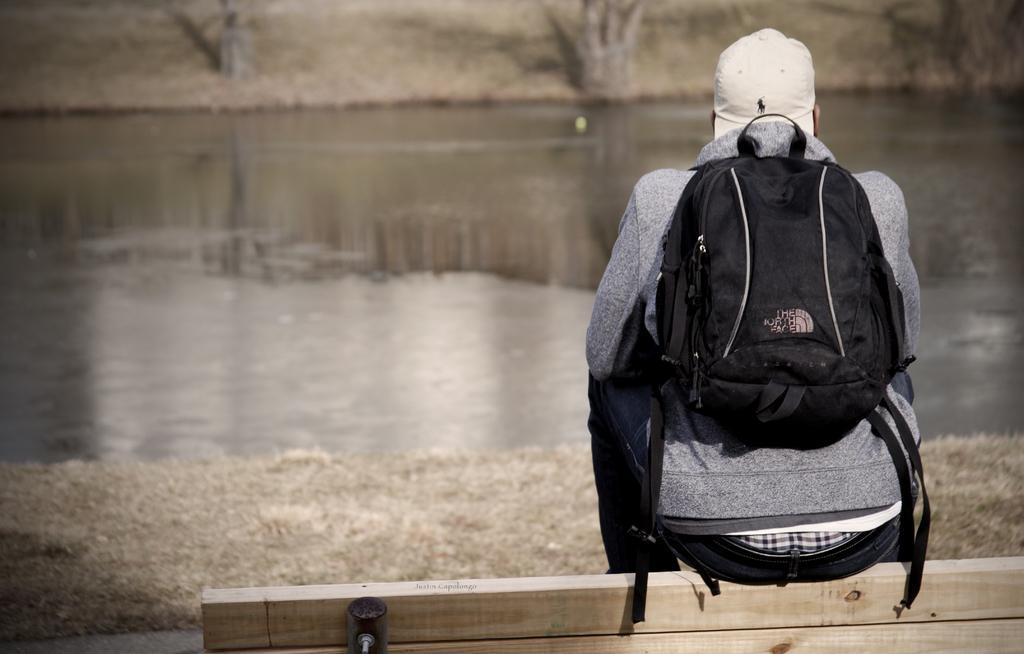Describe this image in one or two sentences. In this image i can see a person wearing bag and sitting on bench at the back ground i can see water and trees. 